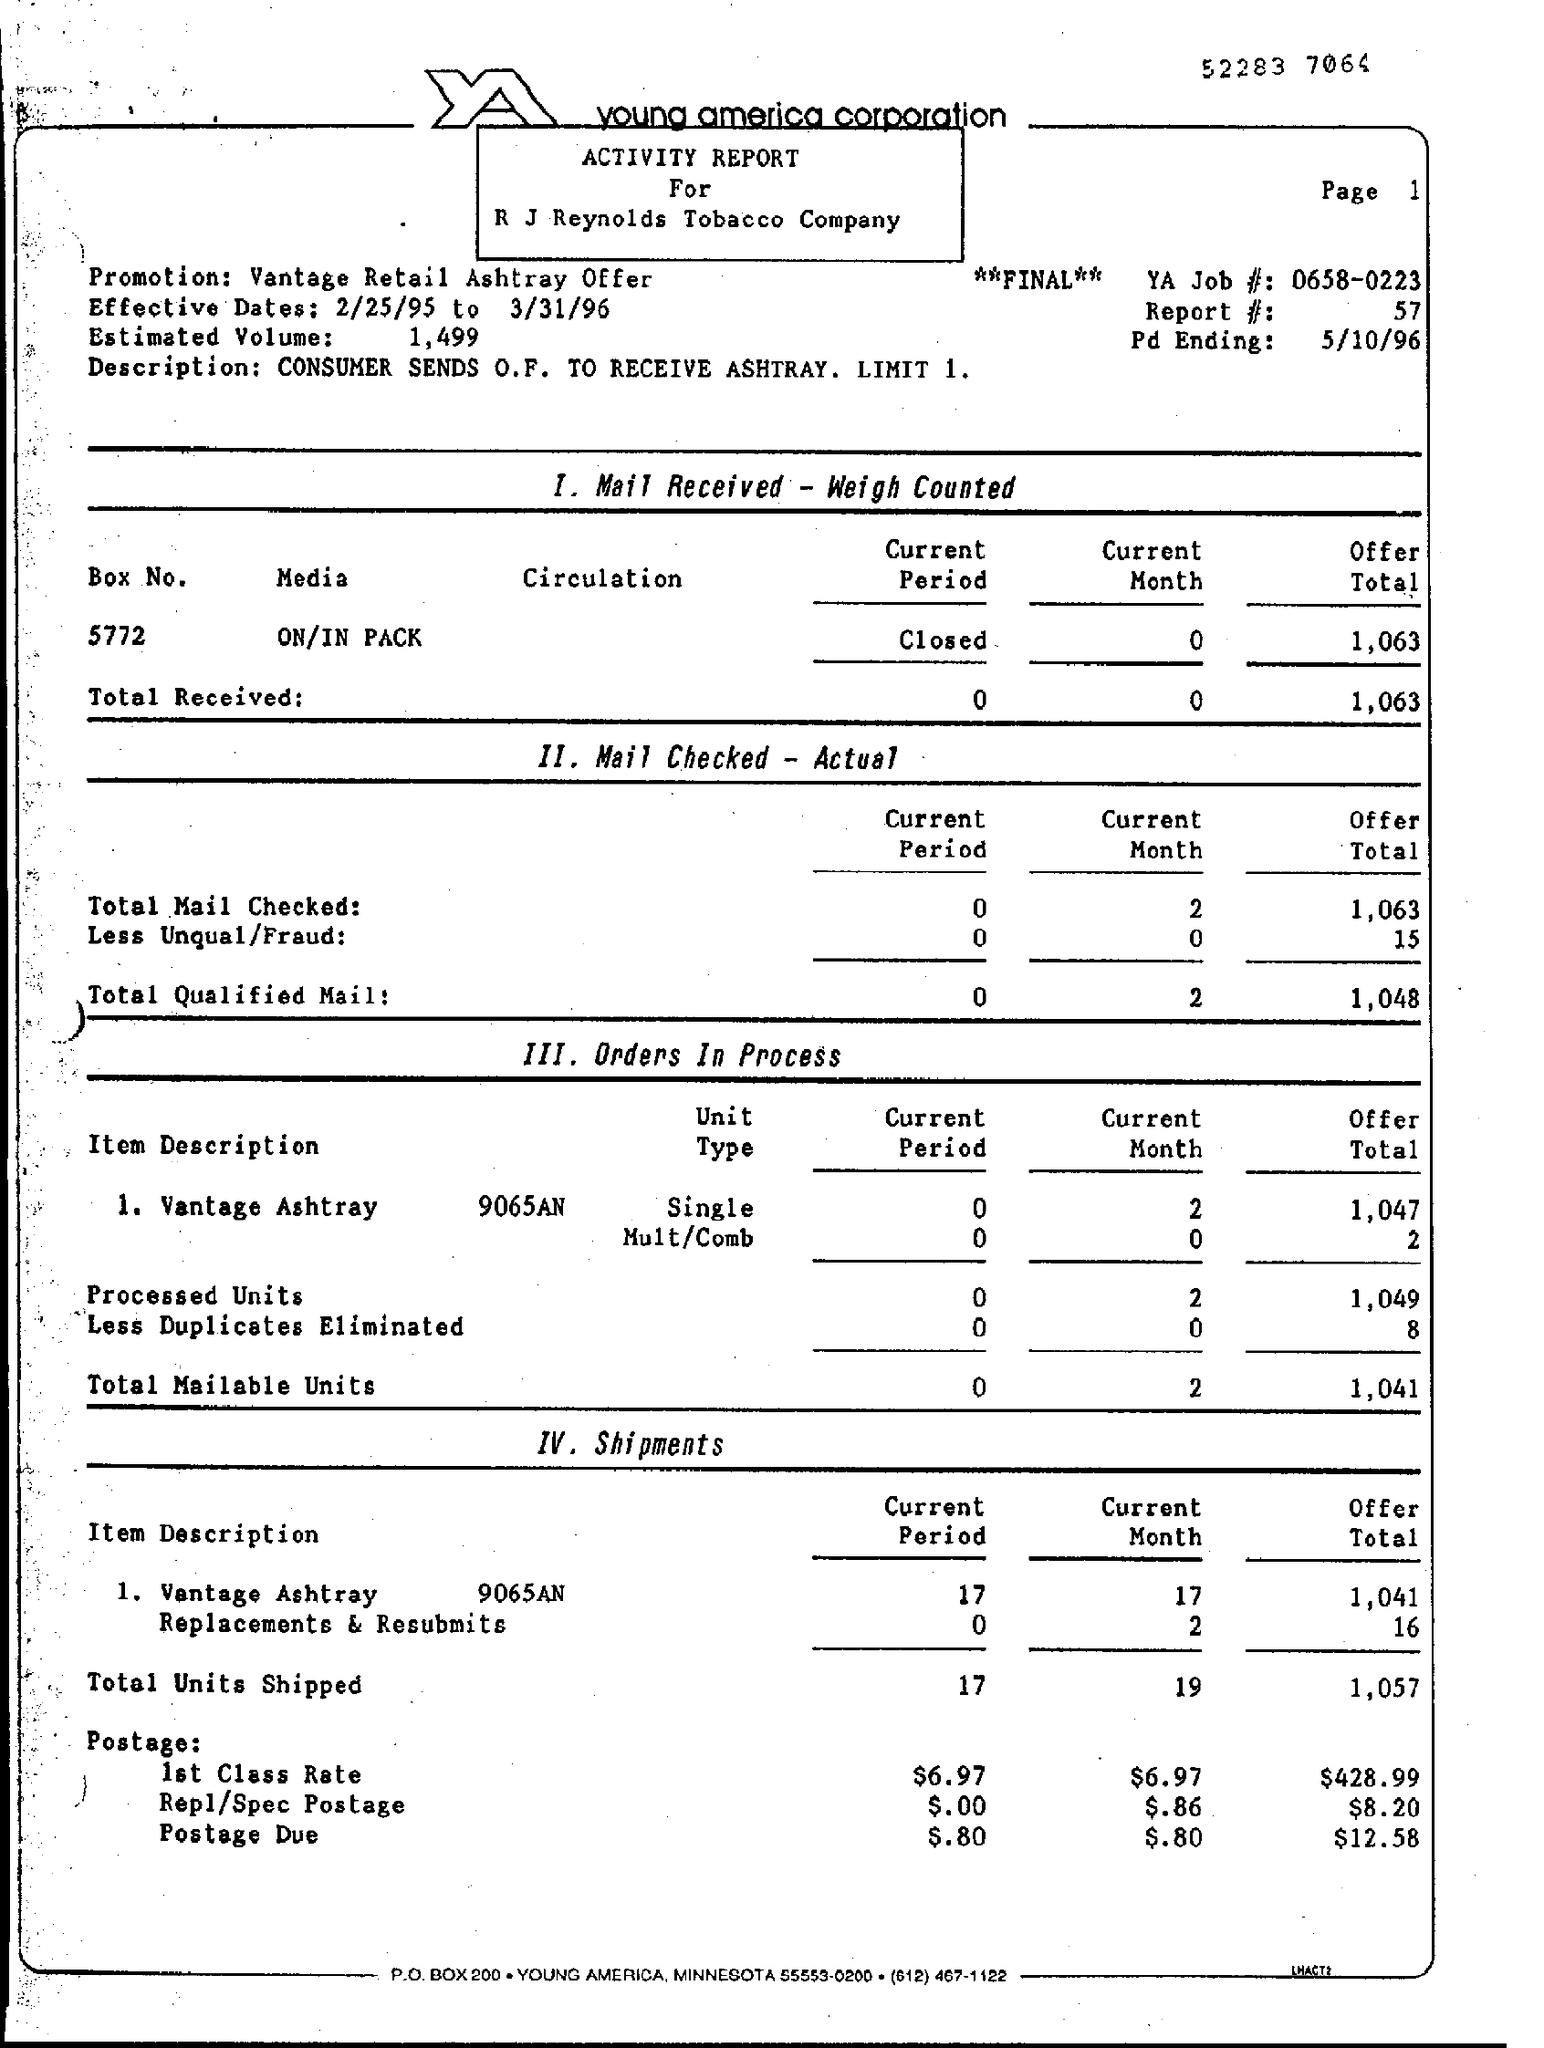Highlight a few significant elements in this photo. A consumer has initiated the process of requesting an ashtray by sending an O.F. (Order Fulfillment) to receive the item. The consumer is limited to one O.F. per order. The effective dates of the mentioned period are from 2/25/95 to 3/31/96. The top of the page mentions Young America Corporation. The document title is an activity report for R J Reynolds Tobacco Company. 